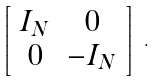Convert formula to latex. <formula><loc_0><loc_0><loc_500><loc_500>\left [ \begin{array} { c c } I _ { N } & 0 \\ 0 & - I _ { N } \end{array} \right ] \ .</formula> 